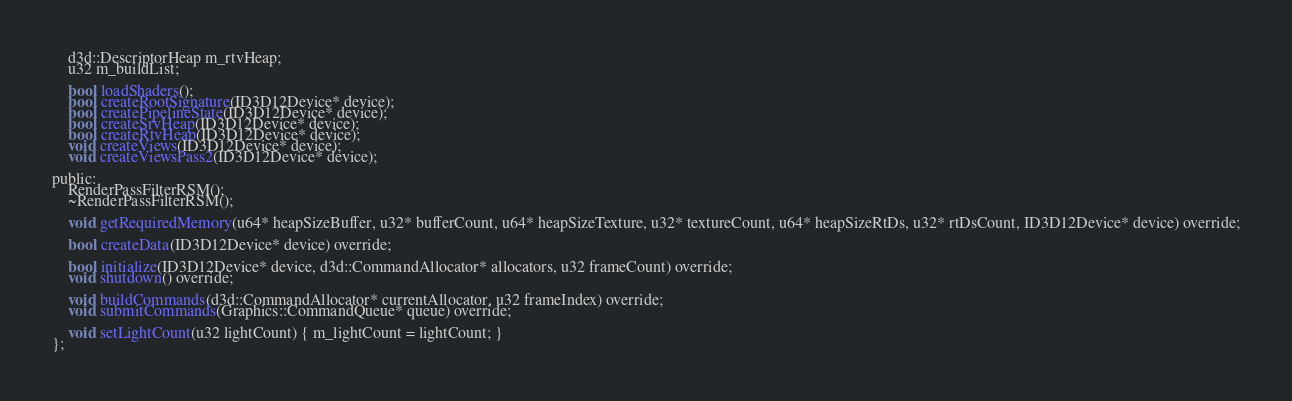<code> <loc_0><loc_0><loc_500><loc_500><_C_>	d3d::DescriptorHeap m_rtvHeap;
	u32 m_buildList;

	bool loadShaders();
	bool createRootSignature(ID3D12Device* device);
	bool createPipelineState(ID3D12Device* device);
	bool createSrvHeap(ID3D12Device* device);
	bool createRtvHeap(ID3D12Device* device);
	void createViews(ID3D12Device* device);
	void createViewsPass2(ID3D12Device* device);

public:
	RenderPassFilterRSM();
	~RenderPassFilterRSM();

	void getRequiredMemory(u64* heapSizeBuffer, u32* bufferCount, u64* heapSizeTexture, u32* textureCount, u64* heapSizeRtDs, u32* rtDsCount, ID3D12Device* device) override;

	bool createData(ID3D12Device* device) override;

	bool initialize(ID3D12Device* device, d3d::CommandAllocator* allocators, u32 frameCount) override;
	void shutdown() override;

	void buildCommands(d3d::CommandAllocator* currentAllocator, u32 frameIndex) override;
	void submitCommands(Graphics::CommandQueue* queue) override;

	void setLightCount(u32 lightCount) { m_lightCount = lightCount; }
};</code> 